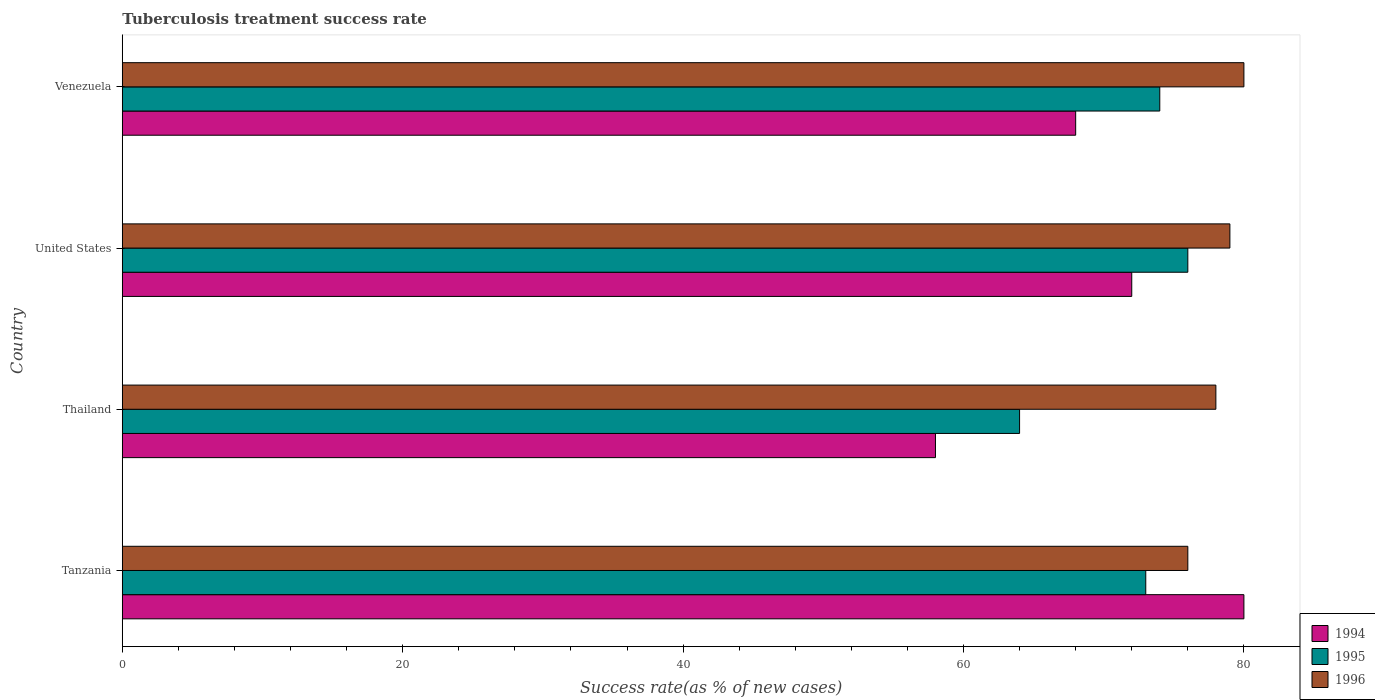How many groups of bars are there?
Your answer should be compact. 4. Are the number of bars per tick equal to the number of legend labels?
Offer a terse response. Yes. How many bars are there on the 3rd tick from the bottom?
Ensure brevity in your answer.  3. What is the label of the 4th group of bars from the top?
Ensure brevity in your answer.  Tanzania. In how many cases, is the number of bars for a given country not equal to the number of legend labels?
Provide a succinct answer. 0. Across all countries, what is the minimum tuberculosis treatment success rate in 1995?
Keep it short and to the point. 64. In which country was the tuberculosis treatment success rate in 1994 minimum?
Ensure brevity in your answer.  Thailand. What is the total tuberculosis treatment success rate in 1995 in the graph?
Your response must be concise. 287. What is the difference between the tuberculosis treatment success rate in 1995 in Tanzania and that in United States?
Ensure brevity in your answer.  -3. What is the average tuberculosis treatment success rate in 1995 per country?
Make the answer very short. 71.75. What is the difference between the tuberculosis treatment success rate in 1996 and tuberculosis treatment success rate in 1995 in Thailand?
Your answer should be compact. 14. In how many countries, is the tuberculosis treatment success rate in 1994 greater than 32 %?
Your answer should be compact. 4. What is the ratio of the tuberculosis treatment success rate in 1995 in United States to that in Venezuela?
Ensure brevity in your answer.  1.03. Is the tuberculosis treatment success rate in 1995 in Thailand less than that in Venezuela?
Your response must be concise. Yes. What is the difference between the highest and the lowest tuberculosis treatment success rate in 1994?
Keep it short and to the point. 22. In how many countries, is the tuberculosis treatment success rate in 1994 greater than the average tuberculosis treatment success rate in 1994 taken over all countries?
Offer a terse response. 2. What does the 2nd bar from the bottom in United States represents?
Your answer should be very brief. 1995. Is it the case that in every country, the sum of the tuberculosis treatment success rate in 1996 and tuberculosis treatment success rate in 1994 is greater than the tuberculosis treatment success rate in 1995?
Keep it short and to the point. Yes. How many bars are there?
Keep it short and to the point. 12. Are all the bars in the graph horizontal?
Make the answer very short. Yes. What is the difference between two consecutive major ticks on the X-axis?
Your answer should be compact. 20. Are the values on the major ticks of X-axis written in scientific E-notation?
Your answer should be very brief. No. Does the graph contain any zero values?
Provide a short and direct response. No. Does the graph contain grids?
Give a very brief answer. No. Where does the legend appear in the graph?
Offer a terse response. Bottom right. How many legend labels are there?
Keep it short and to the point. 3. How are the legend labels stacked?
Make the answer very short. Vertical. What is the title of the graph?
Offer a very short reply. Tuberculosis treatment success rate. Does "1996" appear as one of the legend labels in the graph?
Offer a very short reply. Yes. What is the label or title of the X-axis?
Your answer should be very brief. Success rate(as % of new cases). What is the label or title of the Y-axis?
Your answer should be compact. Country. What is the Success rate(as % of new cases) of 1995 in Tanzania?
Offer a very short reply. 73. What is the Success rate(as % of new cases) of 1996 in Tanzania?
Ensure brevity in your answer.  76. What is the Success rate(as % of new cases) of 1994 in United States?
Your answer should be very brief. 72. What is the Success rate(as % of new cases) in 1995 in United States?
Your response must be concise. 76. What is the Success rate(as % of new cases) in 1996 in United States?
Make the answer very short. 79. What is the Success rate(as % of new cases) of 1994 in Venezuela?
Ensure brevity in your answer.  68. What is the Success rate(as % of new cases) of 1995 in Venezuela?
Ensure brevity in your answer.  74. What is the Success rate(as % of new cases) of 1996 in Venezuela?
Offer a terse response. 80. Across all countries, what is the maximum Success rate(as % of new cases) in 1994?
Your response must be concise. 80. Across all countries, what is the maximum Success rate(as % of new cases) in 1996?
Ensure brevity in your answer.  80. Across all countries, what is the minimum Success rate(as % of new cases) of 1994?
Your response must be concise. 58. What is the total Success rate(as % of new cases) in 1994 in the graph?
Provide a short and direct response. 278. What is the total Success rate(as % of new cases) of 1995 in the graph?
Offer a terse response. 287. What is the total Success rate(as % of new cases) in 1996 in the graph?
Your answer should be very brief. 313. What is the difference between the Success rate(as % of new cases) in 1994 in Tanzania and that in United States?
Provide a short and direct response. 8. What is the difference between the Success rate(as % of new cases) in 1996 in Thailand and that in Venezuela?
Your answer should be very brief. -2. What is the difference between the Success rate(as % of new cases) of 1995 in United States and that in Venezuela?
Offer a very short reply. 2. What is the difference between the Success rate(as % of new cases) in 1996 in United States and that in Venezuela?
Your response must be concise. -1. What is the difference between the Success rate(as % of new cases) of 1994 in Tanzania and the Success rate(as % of new cases) of 1996 in Thailand?
Ensure brevity in your answer.  2. What is the difference between the Success rate(as % of new cases) of 1995 in Tanzania and the Success rate(as % of new cases) of 1996 in Thailand?
Offer a very short reply. -5. What is the difference between the Success rate(as % of new cases) in 1994 in Tanzania and the Success rate(as % of new cases) in 1995 in United States?
Your answer should be very brief. 4. What is the difference between the Success rate(as % of new cases) in 1994 in Tanzania and the Success rate(as % of new cases) in 1996 in United States?
Ensure brevity in your answer.  1. What is the difference between the Success rate(as % of new cases) in 1995 in Tanzania and the Success rate(as % of new cases) in 1996 in United States?
Keep it short and to the point. -6. What is the difference between the Success rate(as % of new cases) in 1994 in Tanzania and the Success rate(as % of new cases) in 1996 in Venezuela?
Offer a very short reply. 0. What is the difference between the Success rate(as % of new cases) of 1994 in Thailand and the Success rate(as % of new cases) of 1996 in United States?
Your response must be concise. -21. What is the difference between the Success rate(as % of new cases) of 1995 in Thailand and the Success rate(as % of new cases) of 1996 in United States?
Make the answer very short. -15. What is the difference between the Success rate(as % of new cases) of 1994 in Thailand and the Success rate(as % of new cases) of 1996 in Venezuela?
Your response must be concise. -22. What is the difference between the Success rate(as % of new cases) of 1995 in Thailand and the Success rate(as % of new cases) of 1996 in Venezuela?
Your response must be concise. -16. What is the difference between the Success rate(as % of new cases) of 1994 in United States and the Success rate(as % of new cases) of 1996 in Venezuela?
Provide a short and direct response. -8. What is the difference between the Success rate(as % of new cases) in 1995 in United States and the Success rate(as % of new cases) in 1996 in Venezuela?
Make the answer very short. -4. What is the average Success rate(as % of new cases) of 1994 per country?
Ensure brevity in your answer.  69.5. What is the average Success rate(as % of new cases) in 1995 per country?
Offer a very short reply. 71.75. What is the average Success rate(as % of new cases) in 1996 per country?
Your answer should be very brief. 78.25. What is the difference between the Success rate(as % of new cases) of 1994 and Success rate(as % of new cases) of 1996 in Tanzania?
Offer a very short reply. 4. What is the difference between the Success rate(as % of new cases) in 1995 and Success rate(as % of new cases) in 1996 in Thailand?
Ensure brevity in your answer.  -14. What is the difference between the Success rate(as % of new cases) in 1995 and Success rate(as % of new cases) in 1996 in United States?
Your answer should be very brief. -3. What is the difference between the Success rate(as % of new cases) in 1994 and Success rate(as % of new cases) in 1995 in Venezuela?
Keep it short and to the point. -6. What is the difference between the Success rate(as % of new cases) of 1994 and Success rate(as % of new cases) of 1996 in Venezuela?
Provide a succinct answer. -12. What is the ratio of the Success rate(as % of new cases) in 1994 in Tanzania to that in Thailand?
Provide a short and direct response. 1.38. What is the ratio of the Success rate(as % of new cases) of 1995 in Tanzania to that in Thailand?
Offer a terse response. 1.14. What is the ratio of the Success rate(as % of new cases) of 1996 in Tanzania to that in Thailand?
Give a very brief answer. 0.97. What is the ratio of the Success rate(as % of new cases) of 1995 in Tanzania to that in United States?
Make the answer very short. 0.96. What is the ratio of the Success rate(as % of new cases) of 1994 in Tanzania to that in Venezuela?
Keep it short and to the point. 1.18. What is the ratio of the Success rate(as % of new cases) in 1995 in Tanzania to that in Venezuela?
Your response must be concise. 0.99. What is the ratio of the Success rate(as % of new cases) in 1994 in Thailand to that in United States?
Offer a terse response. 0.81. What is the ratio of the Success rate(as % of new cases) in 1995 in Thailand to that in United States?
Keep it short and to the point. 0.84. What is the ratio of the Success rate(as % of new cases) in 1996 in Thailand to that in United States?
Provide a succinct answer. 0.99. What is the ratio of the Success rate(as % of new cases) of 1994 in Thailand to that in Venezuela?
Provide a short and direct response. 0.85. What is the ratio of the Success rate(as % of new cases) in 1995 in Thailand to that in Venezuela?
Keep it short and to the point. 0.86. What is the ratio of the Success rate(as % of new cases) of 1996 in Thailand to that in Venezuela?
Provide a succinct answer. 0.97. What is the ratio of the Success rate(as % of new cases) in 1994 in United States to that in Venezuela?
Your response must be concise. 1.06. What is the ratio of the Success rate(as % of new cases) in 1996 in United States to that in Venezuela?
Your response must be concise. 0.99. What is the difference between the highest and the second highest Success rate(as % of new cases) of 1994?
Your answer should be compact. 8. What is the difference between the highest and the second highest Success rate(as % of new cases) of 1995?
Keep it short and to the point. 2. What is the difference between the highest and the second highest Success rate(as % of new cases) in 1996?
Offer a very short reply. 1. What is the difference between the highest and the lowest Success rate(as % of new cases) of 1996?
Offer a very short reply. 4. 